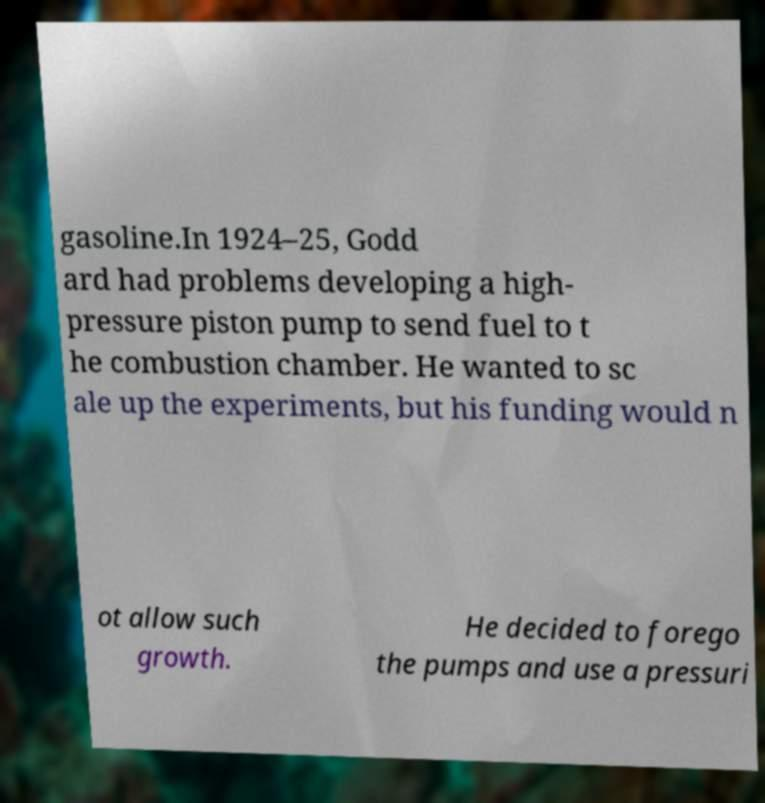Can you read and provide the text displayed in the image?This photo seems to have some interesting text. Can you extract and type it out for me? gasoline.In 1924–25, Godd ard had problems developing a high- pressure piston pump to send fuel to t he combustion chamber. He wanted to sc ale up the experiments, but his funding would n ot allow such growth. He decided to forego the pumps and use a pressuri 